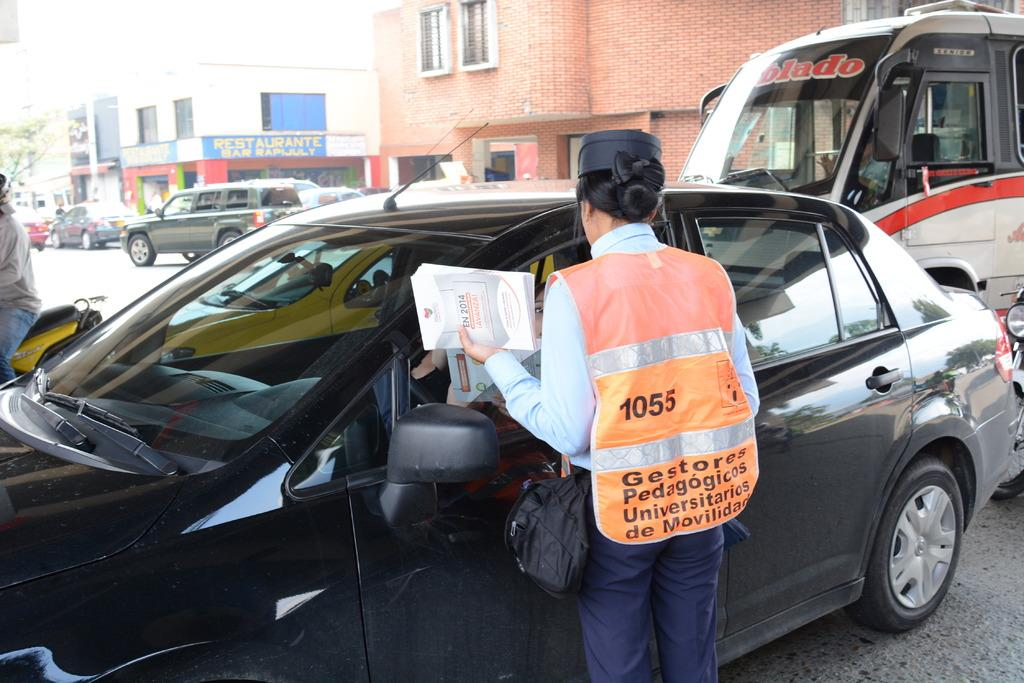<image>
Create a compact narrative representing the image presented. a person with 1055 on their back outside 